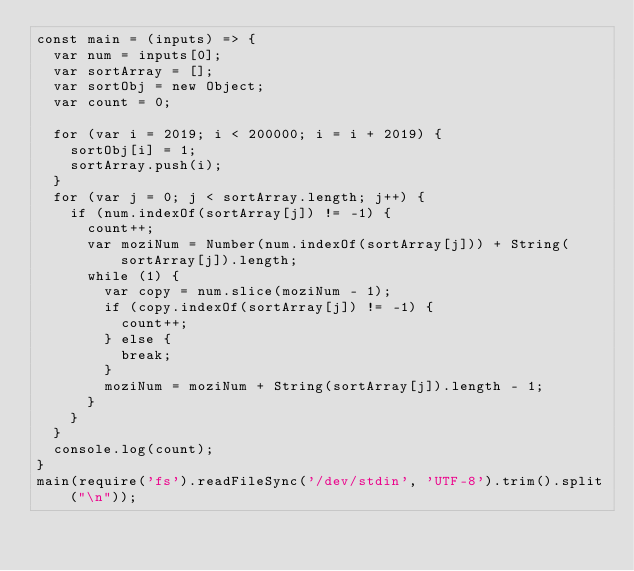<code> <loc_0><loc_0><loc_500><loc_500><_JavaScript_>const main = (inputs) => {
  var num = inputs[0];
  var sortArray = [];
  var sortObj = new Object;
  var count = 0;

  for (var i = 2019; i < 200000; i = i + 2019) {
    sortObj[i] = 1;
    sortArray.push(i);
  }
  for (var j = 0; j < sortArray.length; j++) {
    if (num.indexOf(sortArray[j]) != -1) {
      count++;
      var moziNum = Number(num.indexOf(sortArray[j])) + String(sortArray[j]).length;
      while (1) {
        var copy = num.slice(moziNum - 1);
        if (copy.indexOf(sortArray[j]) != -1) {
          count++;
        } else {
          break;
        }
        moziNum = moziNum + String(sortArray[j]).length - 1;
      }
    }
  }
  console.log(count);
}
main(require('fs').readFileSync('/dev/stdin', 'UTF-8').trim().split("\n"));</code> 